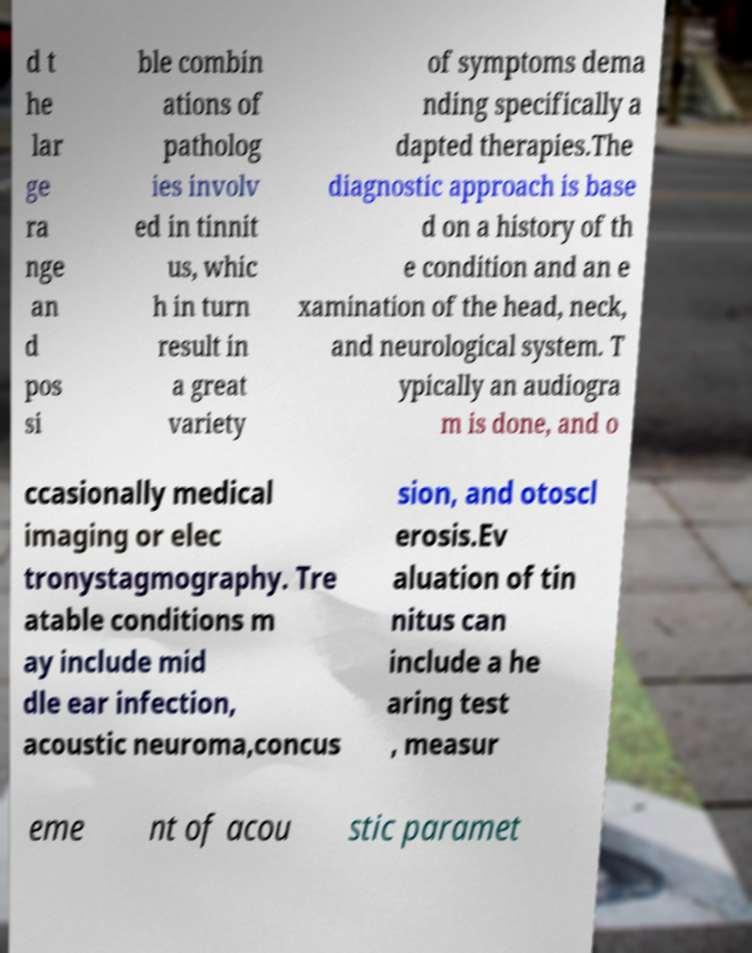Could you assist in decoding the text presented in this image and type it out clearly? d t he lar ge ra nge an d pos si ble combin ations of patholog ies involv ed in tinnit us, whic h in turn result in a great variety of symptoms dema nding specifically a dapted therapies.The diagnostic approach is base d on a history of th e condition and an e xamination of the head, neck, and neurological system. T ypically an audiogra m is done, and o ccasionally medical imaging or elec tronystagmography. Tre atable conditions m ay include mid dle ear infection, acoustic neuroma,concus sion, and otoscl erosis.Ev aluation of tin nitus can include a he aring test , measur eme nt of acou stic paramet 